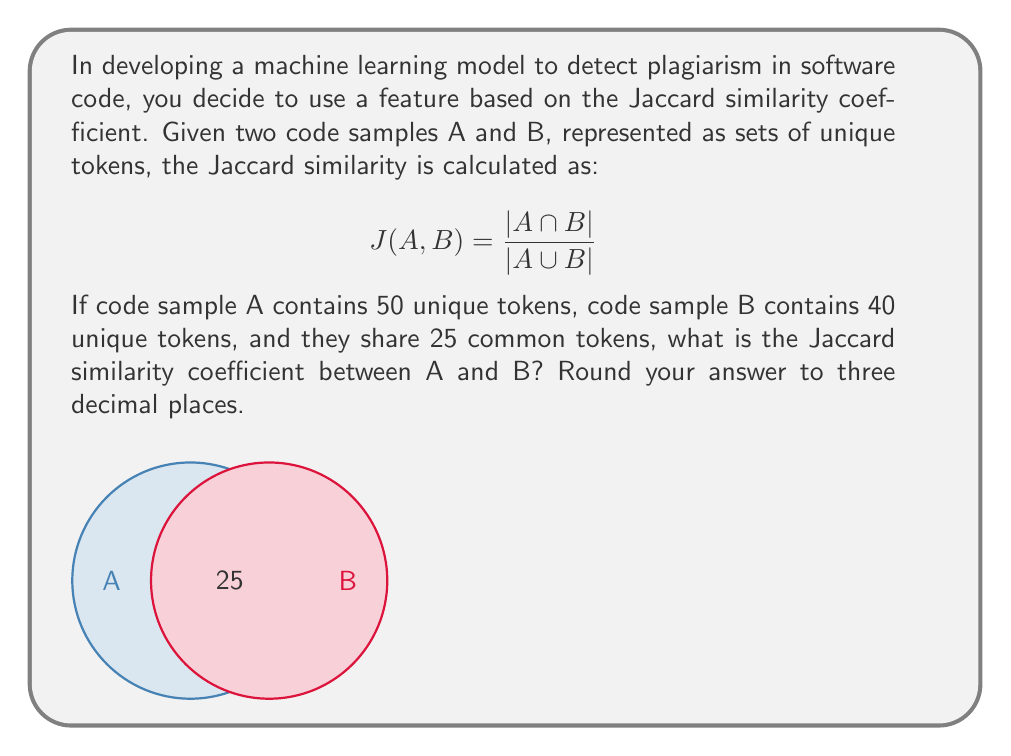Show me your answer to this math problem. Let's approach this step-by-step:

1) We are given:
   - $|A| = 50$ (unique tokens in sample A)
   - $|B| = 40$ (unique tokens in sample B)
   - $|A \cap B| = 25$ (common tokens)

2) We need to find $|A \cup B|$. We can use the principle of inclusion-exclusion:
   $|A \cup B| = |A| + |B| - |A \cap B|$

3) Let's calculate $|A \cup B|$:
   $|A \cup B| = 50 + 40 - 25 = 65$

4) Now we have all the components to calculate the Jaccard similarity:

   $$ J(A,B) = \frac{|A \cap B|}{|A \cup B|} = \frac{25}{65} $$

5) Let's perform the division:
   $\frac{25}{65} \approx 0.3846153846$

6) Rounding to three decimal places:
   $0.385$

Therefore, the Jaccard similarity coefficient between code samples A and B is 0.385.
Answer: 0.385 